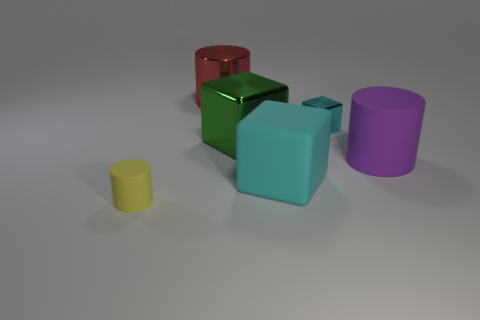Subtract all big blocks. How many blocks are left? 1 Subtract all purple cylinders. How many cylinders are left? 2 Add 6 purple matte cylinders. How many purple matte cylinders are left? 7 Add 2 rubber objects. How many rubber objects exist? 5 Add 1 large cyan matte blocks. How many objects exist? 7 Subtract 0 cyan cylinders. How many objects are left? 6 Subtract 1 blocks. How many blocks are left? 2 Subtract all gray cubes. Subtract all purple cylinders. How many cubes are left? 3 Subtract all cyan cylinders. How many yellow blocks are left? 0 Subtract all big matte blocks. Subtract all large green cubes. How many objects are left? 4 